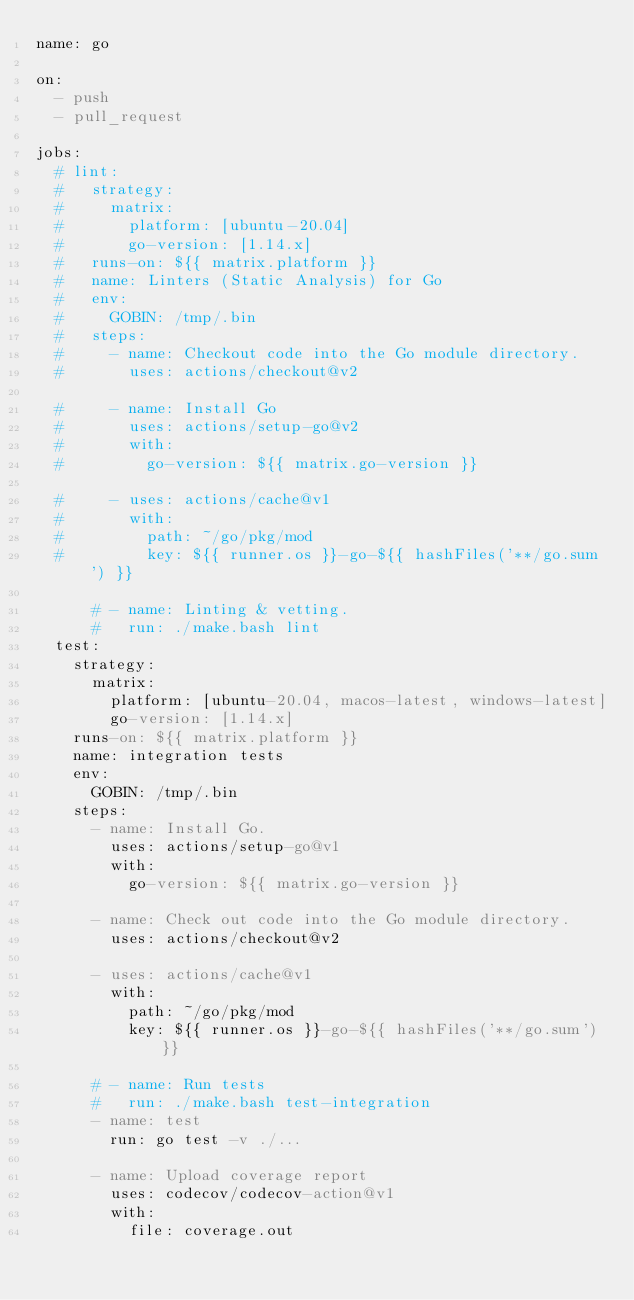<code> <loc_0><loc_0><loc_500><loc_500><_YAML_>name: go

on:
  - push
  - pull_request

jobs:
  # lint:
  #   strategy:
  #     matrix:
  #       platform: [ubuntu-20.04]
  #       go-version: [1.14.x]
  #   runs-on: ${{ matrix.platform }}
  #   name: Linters (Static Analysis) for Go
  #   env:
  #     GOBIN: /tmp/.bin
  #   steps:
  #     - name: Checkout code into the Go module directory.
  #       uses: actions/checkout@v2

  #     - name: Install Go
  #       uses: actions/setup-go@v2
  #       with:
  #         go-version: ${{ matrix.go-version }}

  #     - uses: actions/cache@v1
  #       with:
  #         path: ~/go/pkg/mod
  #         key: ${{ runner.os }}-go-${{ hashFiles('**/go.sum') }}

      # - name: Linting & vetting.
      #   run: ./make.bash lint
  test:
    strategy:
      matrix:
        platform: [ubuntu-20.04, macos-latest, windows-latest]
        go-version: [1.14.x]
    runs-on: ${{ matrix.platform }}
    name: integration tests
    env:
      GOBIN: /tmp/.bin
    steps:
      - name: Install Go.
        uses: actions/setup-go@v1
        with:
          go-version: ${{ matrix.go-version }}

      - name: Check out code into the Go module directory.
        uses: actions/checkout@v2

      - uses: actions/cache@v1
        with:
          path: ~/go/pkg/mod
          key: ${{ runner.os }}-go-${{ hashFiles('**/go.sum') }}

      # - name: Run tests
      #   run: ./make.bash test-integration
      - name: test
        run: go test -v ./...

      - name: Upload coverage report
        uses: codecov/codecov-action@v1
        with:
          file: coverage.out
</code> 